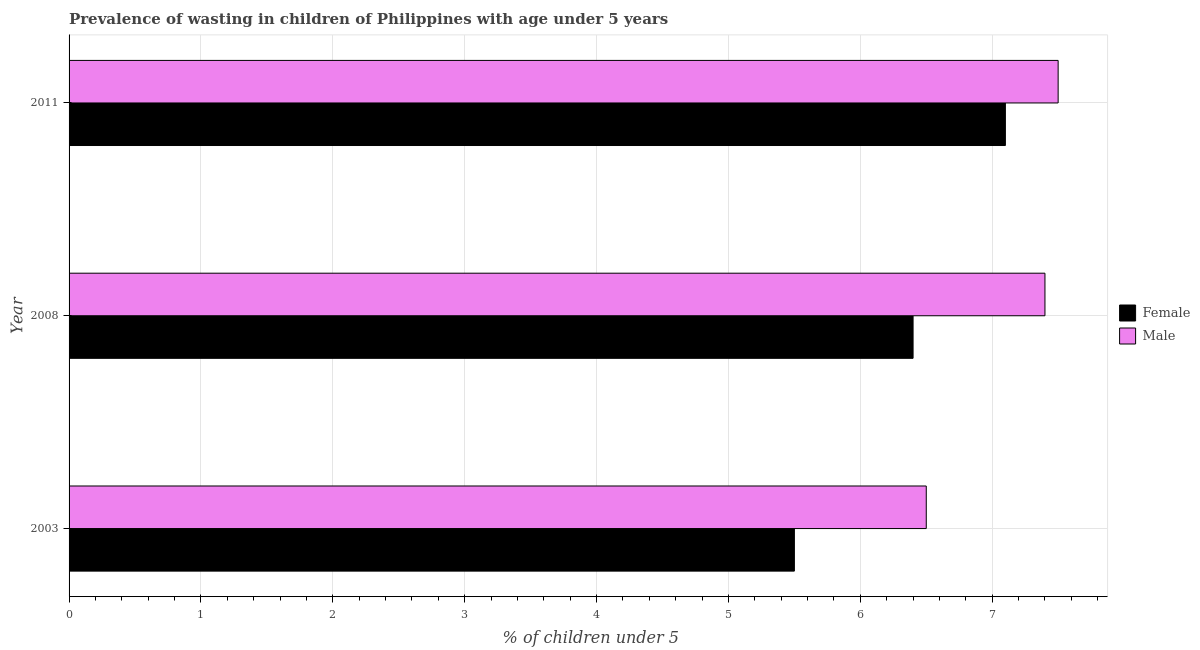Are the number of bars per tick equal to the number of legend labels?
Provide a short and direct response. Yes. Are the number of bars on each tick of the Y-axis equal?
Give a very brief answer. Yes. What is the label of the 1st group of bars from the top?
Provide a succinct answer. 2011. Across all years, what is the maximum percentage of undernourished female children?
Provide a short and direct response. 7.1. Across all years, what is the minimum percentage of undernourished female children?
Your answer should be very brief. 5.5. What is the difference between the percentage of undernourished male children in 2008 and the percentage of undernourished female children in 2011?
Offer a terse response. 0.3. What is the average percentage of undernourished male children per year?
Provide a succinct answer. 7.13. What is the ratio of the percentage of undernourished female children in 2003 to that in 2011?
Ensure brevity in your answer.  0.78. In how many years, is the percentage of undernourished male children greater than the average percentage of undernourished male children taken over all years?
Ensure brevity in your answer.  2. Are the values on the major ticks of X-axis written in scientific E-notation?
Give a very brief answer. No. Where does the legend appear in the graph?
Give a very brief answer. Center right. What is the title of the graph?
Provide a succinct answer. Prevalence of wasting in children of Philippines with age under 5 years. Does "Central government" appear as one of the legend labels in the graph?
Make the answer very short. No. What is the label or title of the X-axis?
Make the answer very short.  % of children under 5. What is the label or title of the Y-axis?
Offer a very short reply. Year. What is the  % of children under 5 in Male in 2003?
Give a very brief answer. 6.5. What is the  % of children under 5 of Female in 2008?
Offer a very short reply. 6.4. What is the  % of children under 5 in Male in 2008?
Your answer should be compact. 7.4. What is the  % of children under 5 in Female in 2011?
Offer a terse response. 7.1. Across all years, what is the maximum  % of children under 5 in Female?
Give a very brief answer. 7.1. What is the total  % of children under 5 in Male in the graph?
Give a very brief answer. 21.4. What is the difference between the  % of children under 5 of Female in 2003 and that in 2008?
Give a very brief answer. -0.9. What is the difference between the  % of children under 5 of Female in 2003 and that in 2011?
Your answer should be very brief. -1.6. What is the difference between the  % of children under 5 of Male in 2008 and that in 2011?
Give a very brief answer. -0.1. What is the difference between the  % of children under 5 in Female in 2008 and the  % of children under 5 in Male in 2011?
Your answer should be very brief. -1.1. What is the average  % of children under 5 of Female per year?
Ensure brevity in your answer.  6.33. What is the average  % of children under 5 of Male per year?
Your answer should be very brief. 7.13. In the year 2011, what is the difference between the  % of children under 5 of Female and  % of children under 5 of Male?
Provide a short and direct response. -0.4. What is the ratio of the  % of children under 5 of Female in 2003 to that in 2008?
Your answer should be compact. 0.86. What is the ratio of the  % of children under 5 in Male in 2003 to that in 2008?
Make the answer very short. 0.88. What is the ratio of the  % of children under 5 in Female in 2003 to that in 2011?
Offer a terse response. 0.77. What is the ratio of the  % of children under 5 in Male in 2003 to that in 2011?
Ensure brevity in your answer.  0.87. What is the ratio of the  % of children under 5 in Female in 2008 to that in 2011?
Your answer should be compact. 0.9. What is the ratio of the  % of children under 5 in Male in 2008 to that in 2011?
Provide a short and direct response. 0.99. What is the difference between the highest and the second highest  % of children under 5 of Male?
Provide a succinct answer. 0.1. What is the difference between the highest and the lowest  % of children under 5 of Male?
Keep it short and to the point. 1. 